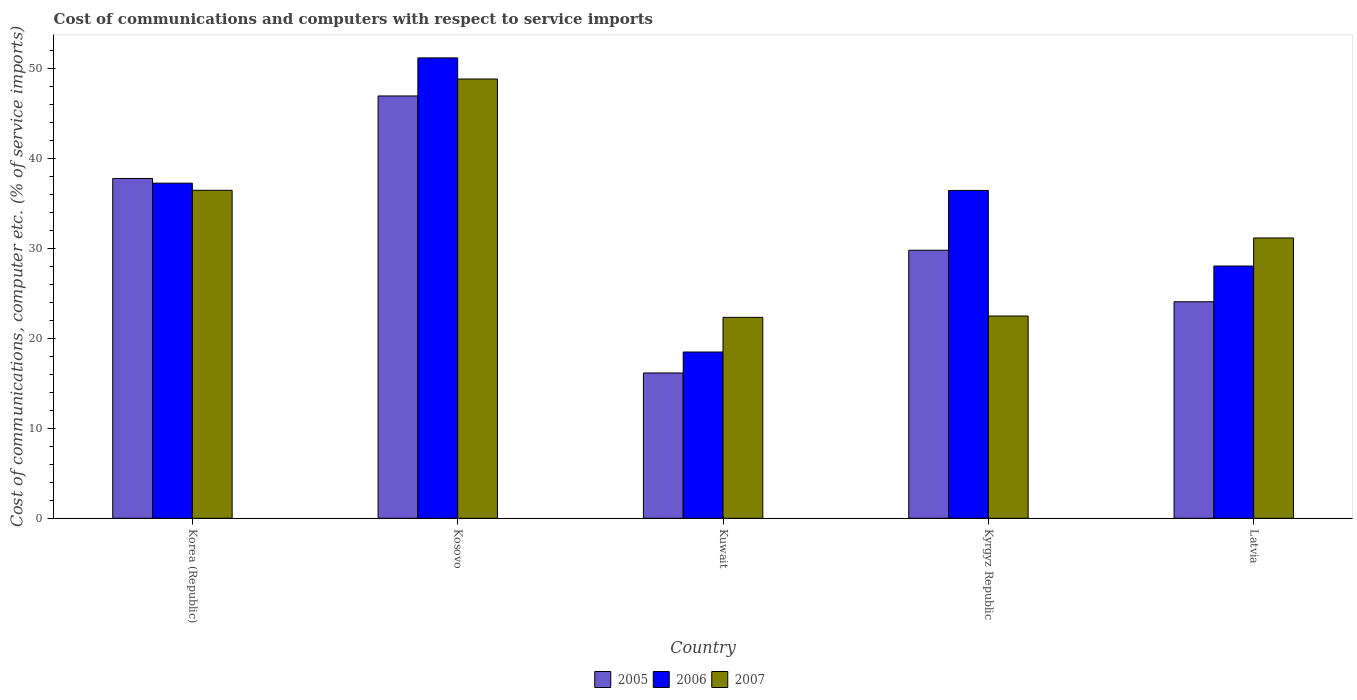How many different coloured bars are there?
Your answer should be very brief. 3. How many bars are there on the 4th tick from the left?
Offer a very short reply. 3. What is the label of the 2nd group of bars from the left?
Provide a short and direct response. Kosovo. What is the cost of communications and computers in 2005 in Korea (Republic)?
Provide a short and direct response. 37.81. Across all countries, what is the maximum cost of communications and computers in 2006?
Offer a very short reply. 51.23. Across all countries, what is the minimum cost of communications and computers in 2006?
Ensure brevity in your answer.  18.5. In which country was the cost of communications and computers in 2007 maximum?
Offer a terse response. Kosovo. In which country was the cost of communications and computers in 2007 minimum?
Offer a very short reply. Kuwait. What is the total cost of communications and computers in 2006 in the graph?
Ensure brevity in your answer.  171.57. What is the difference between the cost of communications and computers in 2005 in Korea (Republic) and that in Kuwait?
Offer a very short reply. 21.64. What is the difference between the cost of communications and computers in 2005 in Kosovo and the cost of communications and computers in 2006 in Korea (Republic)?
Offer a very short reply. 9.7. What is the average cost of communications and computers in 2007 per country?
Your answer should be compact. 32.29. What is the difference between the cost of communications and computers of/in 2006 and cost of communications and computers of/in 2005 in Kosovo?
Give a very brief answer. 4.24. In how many countries, is the cost of communications and computers in 2005 greater than 28 %?
Your answer should be very brief. 3. What is the ratio of the cost of communications and computers in 2006 in Kosovo to that in Latvia?
Your answer should be very brief. 1.83. Is the cost of communications and computers in 2007 in Kosovo less than that in Kuwait?
Your answer should be compact. No. What is the difference between the highest and the second highest cost of communications and computers in 2006?
Ensure brevity in your answer.  14.75. What is the difference between the highest and the lowest cost of communications and computers in 2007?
Offer a very short reply. 26.52. In how many countries, is the cost of communications and computers in 2005 greater than the average cost of communications and computers in 2005 taken over all countries?
Your answer should be compact. 2. What does the 2nd bar from the left in Latvia represents?
Give a very brief answer. 2006. What does the 3rd bar from the right in Kyrgyz Republic represents?
Ensure brevity in your answer.  2005. Are all the bars in the graph horizontal?
Your answer should be very brief. No. What is the difference between two consecutive major ticks on the Y-axis?
Provide a succinct answer. 10. Are the values on the major ticks of Y-axis written in scientific E-notation?
Your response must be concise. No. Does the graph contain grids?
Keep it short and to the point. No. Where does the legend appear in the graph?
Your answer should be very brief. Bottom center. How are the legend labels stacked?
Offer a very short reply. Horizontal. What is the title of the graph?
Keep it short and to the point. Cost of communications and computers with respect to service imports. Does "2010" appear as one of the legend labels in the graph?
Make the answer very short. No. What is the label or title of the X-axis?
Your answer should be compact. Country. What is the label or title of the Y-axis?
Give a very brief answer. Cost of communications, computer etc. (% of service imports). What is the Cost of communications, computer etc. (% of service imports) of 2005 in Korea (Republic)?
Provide a short and direct response. 37.81. What is the Cost of communications, computer etc. (% of service imports) of 2006 in Korea (Republic)?
Your response must be concise. 37.29. What is the Cost of communications, computer etc. (% of service imports) of 2007 in Korea (Republic)?
Give a very brief answer. 36.49. What is the Cost of communications, computer etc. (% of service imports) of 2005 in Kosovo?
Give a very brief answer. 46.99. What is the Cost of communications, computer etc. (% of service imports) in 2006 in Kosovo?
Make the answer very short. 51.23. What is the Cost of communications, computer etc. (% of service imports) of 2007 in Kosovo?
Keep it short and to the point. 48.88. What is the Cost of communications, computer etc. (% of service imports) of 2005 in Kuwait?
Make the answer very short. 16.17. What is the Cost of communications, computer etc. (% of service imports) in 2006 in Kuwait?
Your answer should be very brief. 18.5. What is the Cost of communications, computer etc. (% of service imports) of 2007 in Kuwait?
Provide a short and direct response. 22.36. What is the Cost of communications, computer etc. (% of service imports) in 2005 in Kyrgyz Republic?
Your answer should be compact. 29.83. What is the Cost of communications, computer etc. (% of service imports) of 2006 in Kyrgyz Republic?
Provide a succinct answer. 36.48. What is the Cost of communications, computer etc. (% of service imports) in 2007 in Kyrgyz Republic?
Ensure brevity in your answer.  22.51. What is the Cost of communications, computer etc. (% of service imports) of 2005 in Latvia?
Ensure brevity in your answer.  24.09. What is the Cost of communications, computer etc. (% of service imports) of 2006 in Latvia?
Offer a terse response. 28.07. What is the Cost of communications, computer etc. (% of service imports) of 2007 in Latvia?
Your answer should be very brief. 31.19. Across all countries, what is the maximum Cost of communications, computer etc. (% of service imports) in 2005?
Keep it short and to the point. 46.99. Across all countries, what is the maximum Cost of communications, computer etc. (% of service imports) in 2006?
Give a very brief answer. 51.23. Across all countries, what is the maximum Cost of communications, computer etc. (% of service imports) of 2007?
Provide a short and direct response. 48.88. Across all countries, what is the minimum Cost of communications, computer etc. (% of service imports) of 2005?
Offer a terse response. 16.17. Across all countries, what is the minimum Cost of communications, computer etc. (% of service imports) of 2006?
Ensure brevity in your answer.  18.5. Across all countries, what is the minimum Cost of communications, computer etc. (% of service imports) of 2007?
Offer a very short reply. 22.36. What is the total Cost of communications, computer etc. (% of service imports) of 2005 in the graph?
Your answer should be very brief. 154.88. What is the total Cost of communications, computer etc. (% of service imports) of 2006 in the graph?
Your response must be concise. 171.57. What is the total Cost of communications, computer etc. (% of service imports) in 2007 in the graph?
Ensure brevity in your answer.  161.43. What is the difference between the Cost of communications, computer etc. (% of service imports) in 2005 in Korea (Republic) and that in Kosovo?
Offer a very short reply. -9.18. What is the difference between the Cost of communications, computer etc. (% of service imports) in 2006 in Korea (Republic) and that in Kosovo?
Ensure brevity in your answer.  -13.94. What is the difference between the Cost of communications, computer etc. (% of service imports) of 2007 in Korea (Republic) and that in Kosovo?
Your answer should be compact. -12.39. What is the difference between the Cost of communications, computer etc. (% of service imports) in 2005 in Korea (Republic) and that in Kuwait?
Keep it short and to the point. 21.64. What is the difference between the Cost of communications, computer etc. (% of service imports) in 2006 in Korea (Republic) and that in Kuwait?
Your answer should be compact. 18.79. What is the difference between the Cost of communications, computer etc. (% of service imports) of 2007 in Korea (Republic) and that in Kuwait?
Your answer should be very brief. 14.14. What is the difference between the Cost of communications, computer etc. (% of service imports) of 2005 in Korea (Republic) and that in Kyrgyz Republic?
Provide a short and direct response. 7.98. What is the difference between the Cost of communications, computer etc. (% of service imports) in 2006 in Korea (Republic) and that in Kyrgyz Republic?
Ensure brevity in your answer.  0.81. What is the difference between the Cost of communications, computer etc. (% of service imports) in 2007 in Korea (Republic) and that in Kyrgyz Republic?
Provide a short and direct response. 13.99. What is the difference between the Cost of communications, computer etc. (% of service imports) of 2005 in Korea (Republic) and that in Latvia?
Provide a succinct answer. 13.72. What is the difference between the Cost of communications, computer etc. (% of service imports) in 2006 in Korea (Republic) and that in Latvia?
Keep it short and to the point. 9.22. What is the difference between the Cost of communications, computer etc. (% of service imports) in 2007 in Korea (Republic) and that in Latvia?
Ensure brevity in your answer.  5.3. What is the difference between the Cost of communications, computer etc. (% of service imports) in 2005 in Kosovo and that in Kuwait?
Your answer should be very brief. 30.82. What is the difference between the Cost of communications, computer etc. (% of service imports) of 2006 in Kosovo and that in Kuwait?
Ensure brevity in your answer.  32.73. What is the difference between the Cost of communications, computer etc. (% of service imports) in 2007 in Kosovo and that in Kuwait?
Your response must be concise. 26.52. What is the difference between the Cost of communications, computer etc. (% of service imports) of 2005 in Kosovo and that in Kyrgyz Republic?
Offer a very short reply. 17.17. What is the difference between the Cost of communications, computer etc. (% of service imports) in 2006 in Kosovo and that in Kyrgyz Republic?
Your response must be concise. 14.75. What is the difference between the Cost of communications, computer etc. (% of service imports) in 2007 in Kosovo and that in Kyrgyz Republic?
Your answer should be compact. 26.37. What is the difference between the Cost of communications, computer etc. (% of service imports) in 2005 in Kosovo and that in Latvia?
Make the answer very short. 22.9. What is the difference between the Cost of communications, computer etc. (% of service imports) in 2006 in Kosovo and that in Latvia?
Offer a very short reply. 23.16. What is the difference between the Cost of communications, computer etc. (% of service imports) of 2007 in Kosovo and that in Latvia?
Offer a terse response. 17.69. What is the difference between the Cost of communications, computer etc. (% of service imports) in 2005 in Kuwait and that in Kyrgyz Republic?
Offer a very short reply. -13.66. What is the difference between the Cost of communications, computer etc. (% of service imports) in 2006 in Kuwait and that in Kyrgyz Republic?
Offer a very short reply. -17.98. What is the difference between the Cost of communications, computer etc. (% of service imports) of 2007 in Kuwait and that in Kyrgyz Republic?
Ensure brevity in your answer.  -0.15. What is the difference between the Cost of communications, computer etc. (% of service imports) of 2005 in Kuwait and that in Latvia?
Your response must be concise. -7.92. What is the difference between the Cost of communications, computer etc. (% of service imports) in 2006 in Kuwait and that in Latvia?
Make the answer very short. -9.57. What is the difference between the Cost of communications, computer etc. (% of service imports) in 2007 in Kuwait and that in Latvia?
Provide a short and direct response. -8.83. What is the difference between the Cost of communications, computer etc. (% of service imports) in 2005 in Kyrgyz Republic and that in Latvia?
Offer a terse response. 5.74. What is the difference between the Cost of communications, computer etc. (% of service imports) in 2006 in Kyrgyz Republic and that in Latvia?
Give a very brief answer. 8.41. What is the difference between the Cost of communications, computer etc. (% of service imports) of 2007 in Kyrgyz Republic and that in Latvia?
Offer a terse response. -8.69. What is the difference between the Cost of communications, computer etc. (% of service imports) of 2005 in Korea (Republic) and the Cost of communications, computer etc. (% of service imports) of 2006 in Kosovo?
Offer a terse response. -13.42. What is the difference between the Cost of communications, computer etc. (% of service imports) of 2005 in Korea (Republic) and the Cost of communications, computer etc. (% of service imports) of 2007 in Kosovo?
Give a very brief answer. -11.07. What is the difference between the Cost of communications, computer etc. (% of service imports) of 2006 in Korea (Republic) and the Cost of communications, computer etc. (% of service imports) of 2007 in Kosovo?
Ensure brevity in your answer.  -11.59. What is the difference between the Cost of communications, computer etc. (% of service imports) of 2005 in Korea (Republic) and the Cost of communications, computer etc. (% of service imports) of 2006 in Kuwait?
Make the answer very short. 19.31. What is the difference between the Cost of communications, computer etc. (% of service imports) of 2005 in Korea (Republic) and the Cost of communications, computer etc. (% of service imports) of 2007 in Kuwait?
Offer a terse response. 15.45. What is the difference between the Cost of communications, computer etc. (% of service imports) in 2006 in Korea (Republic) and the Cost of communications, computer etc. (% of service imports) in 2007 in Kuwait?
Your answer should be compact. 14.93. What is the difference between the Cost of communications, computer etc. (% of service imports) in 2005 in Korea (Republic) and the Cost of communications, computer etc. (% of service imports) in 2006 in Kyrgyz Republic?
Ensure brevity in your answer.  1.33. What is the difference between the Cost of communications, computer etc. (% of service imports) in 2005 in Korea (Republic) and the Cost of communications, computer etc. (% of service imports) in 2007 in Kyrgyz Republic?
Your answer should be compact. 15.3. What is the difference between the Cost of communications, computer etc. (% of service imports) of 2006 in Korea (Republic) and the Cost of communications, computer etc. (% of service imports) of 2007 in Kyrgyz Republic?
Offer a terse response. 14.78. What is the difference between the Cost of communications, computer etc. (% of service imports) of 2005 in Korea (Republic) and the Cost of communications, computer etc. (% of service imports) of 2006 in Latvia?
Offer a terse response. 9.74. What is the difference between the Cost of communications, computer etc. (% of service imports) in 2005 in Korea (Republic) and the Cost of communications, computer etc. (% of service imports) in 2007 in Latvia?
Keep it short and to the point. 6.62. What is the difference between the Cost of communications, computer etc. (% of service imports) in 2006 in Korea (Republic) and the Cost of communications, computer etc. (% of service imports) in 2007 in Latvia?
Offer a very short reply. 6.1. What is the difference between the Cost of communications, computer etc. (% of service imports) of 2005 in Kosovo and the Cost of communications, computer etc. (% of service imports) of 2006 in Kuwait?
Give a very brief answer. 28.49. What is the difference between the Cost of communications, computer etc. (% of service imports) in 2005 in Kosovo and the Cost of communications, computer etc. (% of service imports) in 2007 in Kuwait?
Your answer should be very brief. 24.63. What is the difference between the Cost of communications, computer etc. (% of service imports) of 2006 in Kosovo and the Cost of communications, computer etc. (% of service imports) of 2007 in Kuwait?
Keep it short and to the point. 28.87. What is the difference between the Cost of communications, computer etc. (% of service imports) in 2005 in Kosovo and the Cost of communications, computer etc. (% of service imports) in 2006 in Kyrgyz Republic?
Provide a succinct answer. 10.51. What is the difference between the Cost of communications, computer etc. (% of service imports) of 2005 in Kosovo and the Cost of communications, computer etc. (% of service imports) of 2007 in Kyrgyz Republic?
Your answer should be compact. 24.49. What is the difference between the Cost of communications, computer etc. (% of service imports) of 2006 in Kosovo and the Cost of communications, computer etc. (% of service imports) of 2007 in Kyrgyz Republic?
Make the answer very short. 28.72. What is the difference between the Cost of communications, computer etc. (% of service imports) of 2005 in Kosovo and the Cost of communications, computer etc. (% of service imports) of 2006 in Latvia?
Make the answer very short. 18.92. What is the difference between the Cost of communications, computer etc. (% of service imports) in 2005 in Kosovo and the Cost of communications, computer etc. (% of service imports) in 2007 in Latvia?
Keep it short and to the point. 15.8. What is the difference between the Cost of communications, computer etc. (% of service imports) in 2006 in Kosovo and the Cost of communications, computer etc. (% of service imports) in 2007 in Latvia?
Give a very brief answer. 20.04. What is the difference between the Cost of communications, computer etc. (% of service imports) of 2005 in Kuwait and the Cost of communications, computer etc. (% of service imports) of 2006 in Kyrgyz Republic?
Your answer should be compact. -20.31. What is the difference between the Cost of communications, computer etc. (% of service imports) of 2005 in Kuwait and the Cost of communications, computer etc. (% of service imports) of 2007 in Kyrgyz Republic?
Your answer should be very brief. -6.34. What is the difference between the Cost of communications, computer etc. (% of service imports) in 2006 in Kuwait and the Cost of communications, computer etc. (% of service imports) in 2007 in Kyrgyz Republic?
Your answer should be very brief. -4.01. What is the difference between the Cost of communications, computer etc. (% of service imports) in 2005 in Kuwait and the Cost of communications, computer etc. (% of service imports) in 2006 in Latvia?
Provide a succinct answer. -11.9. What is the difference between the Cost of communications, computer etc. (% of service imports) in 2005 in Kuwait and the Cost of communications, computer etc. (% of service imports) in 2007 in Latvia?
Give a very brief answer. -15.02. What is the difference between the Cost of communications, computer etc. (% of service imports) in 2006 in Kuwait and the Cost of communications, computer etc. (% of service imports) in 2007 in Latvia?
Ensure brevity in your answer.  -12.69. What is the difference between the Cost of communications, computer etc. (% of service imports) of 2005 in Kyrgyz Republic and the Cost of communications, computer etc. (% of service imports) of 2006 in Latvia?
Offer a very short reply. 1.76. What is the difference between the Cost of communications, computer etc. (% of service imports) in 2005 in Kyrgyz Republic and the Cost of communications, computer etc. (% of service imports) in 2007 in Latvia?
Your response must be concise. -1.37. What is the difference between the Cost of communications, computer etc. (% of service imports) of 2006 in Kyrgyz Republic and the Cost of communications, computer etc. (% of service imports) of 2007 in Latvia?
Give a very brief answer. 5.29. What is the average Cost of communications, computer etc. (% of service imports) of 2005 per country?
Make the answer very short. 30.98. What is the average Cost of communications, computer etc. (% of service imports) of 2006 per country?
Offer a terse response. 34.31. What is the average Cost of communications, computer etc. (% of service imports) in 2007 per country?
Make the answer very short. 32.29. What is the difference between the Cost of communications, computer etc. (% of service imports) of 2005 and Cost of communications, computer etc. (% of service imports) of 2006 in Korea (Republic)?
Ensure brevity in your answer.  0.52. What is the difference between the Cost of communications, computer etc. (% of service imports) of 2005 and Cost of communications, computer etc. (% of service imports) of 2007 in Korea (Republic)?
Offer a very short reply. 1.32. What is the difference between the Cost of communications, computer etc. (% of service imports) of 2006 and Cost of communications, computer etc. (% of service imports) of 2007 in Korea (Republic)?
Provide a succinct answer. 0.8. What is the difference between the Cost of communications, computer etc. (% of service imports) in 2005 and Cost of communications, computer etc. (% of service imports) in 2006 in Kosovo?
Provide a succinct answer. -4.24. What is the difference between the Cost of communications, computer etc. (% of service imports) in 2005 and Cost of communications, computer etc. (% of service imports) in 2007 in Kosovo?
Provide a succinct answer. -1.89. What is the difference between the Cost of communications, computer etc. (% of service imports) of 2006 and Cost of communications, computer etc. (% of service imports) of 2007 in Kosovo?
Make the answer very short. 2.35. What is the difference between the Cost of communications, computer etc. (% of service imports) of 2005 and Cost of communications, computer etc. (% of service imports) of 2006 in Kuwait?
Offer a very short reply. -2.33. What is the difference between the Cost of communications, computer etc. (% of service imports) in 2005 and Cost of communications, computer etc. (% of service imports) in 2007 in Kuwait?
Your answer should be very brief. -6.19. What is the difference between the Cost of communications, computer etc. (% of service imports) of 2006 and Cost of communications, computer etc. (% of service imports) of 2007 in Kuwait?
Your answer should be compact. -3.86. What is the difference between the Cost of communications, computer etc. (% of service imports) of 2005 and Cost of communications, computer etc. (% of service imports) of 2006 in Kyrgyz Republic?
Give a very brief answer. -6.65. What is the difference between the Cost of communications, computer etc. (% of service imports) of 2005 and Cost of communications, computer etc. (% of service imports) of 2007 in Kyrgyz Republic?
Provide a short and direct response. 7.32. What is the difference between the Cost of communications, computer etc. (% of service imports) in 2006 and Cost of communications, computer etc. (% of service imports) in 2007 in Kyrgyz Republic?
Ensure brevity in your answer.  13.97. What is the difference between the Cost of communications, computer etc. (% of service imports) in 2005 and Cost of communications, computer etc. (% of service imports) in 2006 in Latvia?
Provide a short and direct response. -3.98. What is the difference between the Cost of communications, computer etc. (% of service imports) of 2005 and Cost of communications, computer etc. (% of service imports) of 2007 in Latvia?
Make the answer very short. -7.1. What is the difference between the Cost of communications, computer etc. (% of service imports) in 2006 and Cost of communications, computer etc. (% of service imports) in 2007 in Latvia?
Provide a succinct answer. -3.12. What is the ratio of the Cost of communications, computer etc. (% of service imports) in 2005 in Korea (Republic) to that in Kosovo?
Ensure brevity in your answer.  0.8. What is the ratio of the Cost of communications, computer etc. (% of service imports) of 2006 in Korea (Republic) to that in Kosovo?
Your answer should be very brief. 0.73. What is the ratio of the Cost of communications, computer etc. (% of service imports) in 2007 in Korea (Republic) to that in Kosovo?
Your answer should be very brief. 0.75. What is the ratio of the Cost of communications, computer etc. (% of service imports) of 2005 in Korea (Republic) to that in Kuwait?
Make the answer very short. 2.34. What is the ratio of the Cost of communications, computer etc. (% of service imports) of 2006 in Korea (Republic) to that in Kuwait?
Provide a succinct answer. 2.02. What is the ratio of the Cost of communications, computer etc. (% of service imports) of 2007 in Korea (Republic) to that in Kuwait?
Your answer should be very brief. 1.63. What is the ratio of the Cost of communications, computer etc. (% of service imports) in 2005 in Korea (Republic) to that in Kyrgyz Republic?
Offer a very short reply. 1.27. What is the ratio of the Cost of communications, computer etc. (% of service imports) in 2006 in Korea (Republic) to that in Kyrgyz Republic?
Keep it short and to the point. 1.02. What is the ratio of the Cost of communications, computer etc. (% of service imports) of 2007 in Korea (Republic) to that in Kyrgyz Republic?
Make the answer very short. 1.62. What is the ratio of the Cost of communications, computer etc. (% of service imports) of 2005 in Korea (Republic) to that in Latvia?
Make the answer very short. 1.57. What is the ratio of the Cost of communications, computer etc. (% of service imports) in 2006 in Korea (Republic) to that in Latvia?
Keep it short and to the point. 1.33. What is the ratio of the Cost of communications, computer etc. (% of service imports) in 2007 in Korea (Republic) to that in Latvia?
Make the answer very short. 1.17. What is the ratio of the Cost of communications, computer etc. (% of service imports) in 2005 in Kosovo to that in Kuwait?
Offer a terse response. 2.91. What is the ratio of the Cost of communications, computer etc. (% of service imports) in 2006 in Kosovo to that in Kuwait?
Your answer should be very brief. 2.77. What is the ratio of the Cost of communications, computer etc. (% of service imports) in 2007 in Kosovo to that in Kuwait?
Provide a succinct answer. 2.19. What is the ratio of the Cost of communications, computer etc. (% of service imports) of 2005 in Kosovo to that in Kyrgyz Republic?
Offer a very short reply. 1.58. What is the ratio of the Cost of communications, computer etc. (% of service imports) of 2006 in Kosovo to that in Kyrgyz Republic?
Make the answer very short. 1.4. What is the ratio of the Cost of communications, computer etc. (% of service imports) in 2007 in Kosovo to that in Kyrgyz Republic?
Your answer should be very brief. 2.17. What is the ratio of the Cost of communications, computer etc. (% of service imports) of 2005 in Kosovo to that in Latvia?
Provide a succinct answer. 1.95. What is the ratio of the Cost of communications, computer etc. (% of service imports) of 2006 in Kosovo to that in Latvia?
Make the answer very short. 1.82. What is the ratio of the Cost of communications, computer etc. (% of service imports) in 2007 in Kosovo to that in Latvia?
Make the answer very short. 1.57. What is the ratio of the Cost of communications, computer etc. (% of service imports) of 2005 in Kuwait to that in Kyrgyz Republic?
Your response must be concise. 0.54. What is the ratio of the Cost of communications, computer etc. (% of service imports) of 2006 in Kuwait to that in Kyrgyz Republic?
Provide a short and direct response. 0.51. What is the ratio of the Cost of communications, computer etc. (% of service imports) in 2007 in Kuwait to that in Kyrgyz Republic?
Ensure brevity in your answer.  0.99. What is the ratio of the Cost of communications, computer etc. (% of service imports) in 2005 in Kuwait to that in Latvia?
Give a very brief answer. 0.67. What is the ratio of the Cost of communications, computer etc. (% of service imports) of 2006 in Kuwait to that in Latvia?
Offer a terse response. 0.66. What is the ratio of the Cost of communications, computer etc. (% of service imports) of 2007 in Kuwait to that in Latvia?
Make the answer very short. 0.72. What is the ratio of the Cost of communications, computer etc. (% of service imports) of 2005 in Kyrgyz Republic to that in Latvia?
Your response must be concise. 1.24. What is the ratio of the Cost of communications, computer etc. (% of service imports) in 2006 in Kyrgyz Republic to that in Latvia?
Provide a succinct answer. 1.3. What is the ratio of the Cost of communications, computer etc. (% of service imports) of 2007 in Kyrgyz Republic to that in Latvia?
Offer a very short reply. 0.72. What is the difference between the highest and the second highest Cost of communications, computer etc. (% of service imports) of 2005?
Your answer should be very brief. 9.18. What is the difference between the highest and the second highest Cost of communications, computer etc. (% of service imports) in 2006?
Keep it short and to the point. 13.94. What is the difference between the highest and the second highest Cost of communications, computer etc. (% of service imports) in 2007?
Keep it short and to the point. 12.39. What is the difference between the highest and the lowest Cost of communications, computer etc. (% of service imports) in 2005?
Your answer should be compact. 30.82. What is the difference between the highest and the lowest Cost of communications, computer etc. (% of service imports) in 2006?
Your answer should be compact. 32.73. What is the difference between the highest and the lowest Cost of communications, computer etc. (% of service imports) of 2007?
Your answer should be very brief. 26.52. 